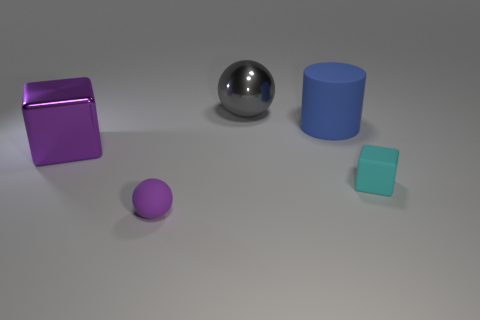Subtract all blue blocks. Subtract all purple cylinders. How many blocks are left? 2 Add 4 tiny gray things. How many objects exist? 9 Subtract all balls. How many objects are left? 3 Subtract 0 yellow cylinders. How many objects are left? 5 Subtract all yellow matte things. Subtract all small cyan blocks. How many objects are left? 4 Add 4 tiny cyan matte objects. How many tiny cyan matte objects are left? 5 Add 3 matte blocks. How many matte blocks exist? 4 